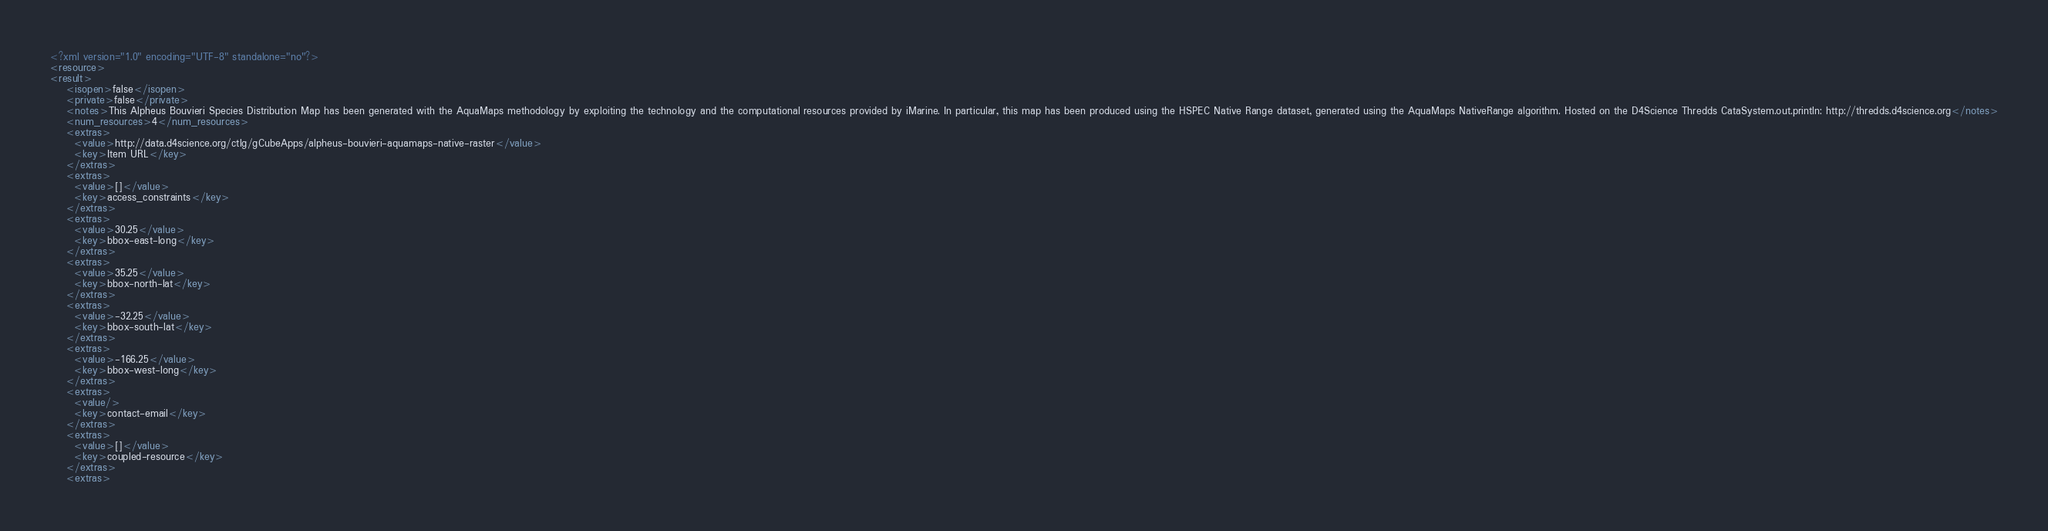Convert code to text. <code><loc_0><loc_0><loc_500><loc_500><_XML_><?xml version="1.0" encoding="UTF-8" standalone="no"?>
<resource>
<result>
    <isopen>false</isopen>
    <private>false</private>
    <notes>This Alpheus Bouvieri Species Distribution Map has been generated with the AquaMaps methodology by exploiting the technology and the computational resources provided by iMarine. In particular, this map has been produced using the HSPEC Native Range dataset, generated using the AquaMaps NativeRange algorithm. Hosted on the D4Science Thredds CataSystem.out.println: http://thredds.d4science.org</notes>
    <num_resources>4</num_resources>
    <extras>
      <value>http://data.d4science.org/ctlg/gCubeApps/alpheus-bouvieri-aquamaps-native-raster</value>
      <key>Item URL</key>
    </extras>
    <extras>
      <value>[]</value>
      <key>access_constraints</key>
    </extras>
    <extras>
      <value>30.25</value>
      <key>bbox-east-long</key>
    </extras>
    <extras>
      <value>35.25</value>
      <key>bbox-north-lat</key>
    </extras>
    <extras>
      <value>-32.25</value>
      <key>bbox-south-lat</key>
    </extras>
    <extras>
      <value>-166.25</value>
      <key>bbox-west-long</key>
    </extras>
    <extras>
      <value/>
      <key>contact-email</key>
    </extras>
    <extras>
      <value>[]</value>
      <key>coupled-resource</key>
    </extras>
    <extras></code> 